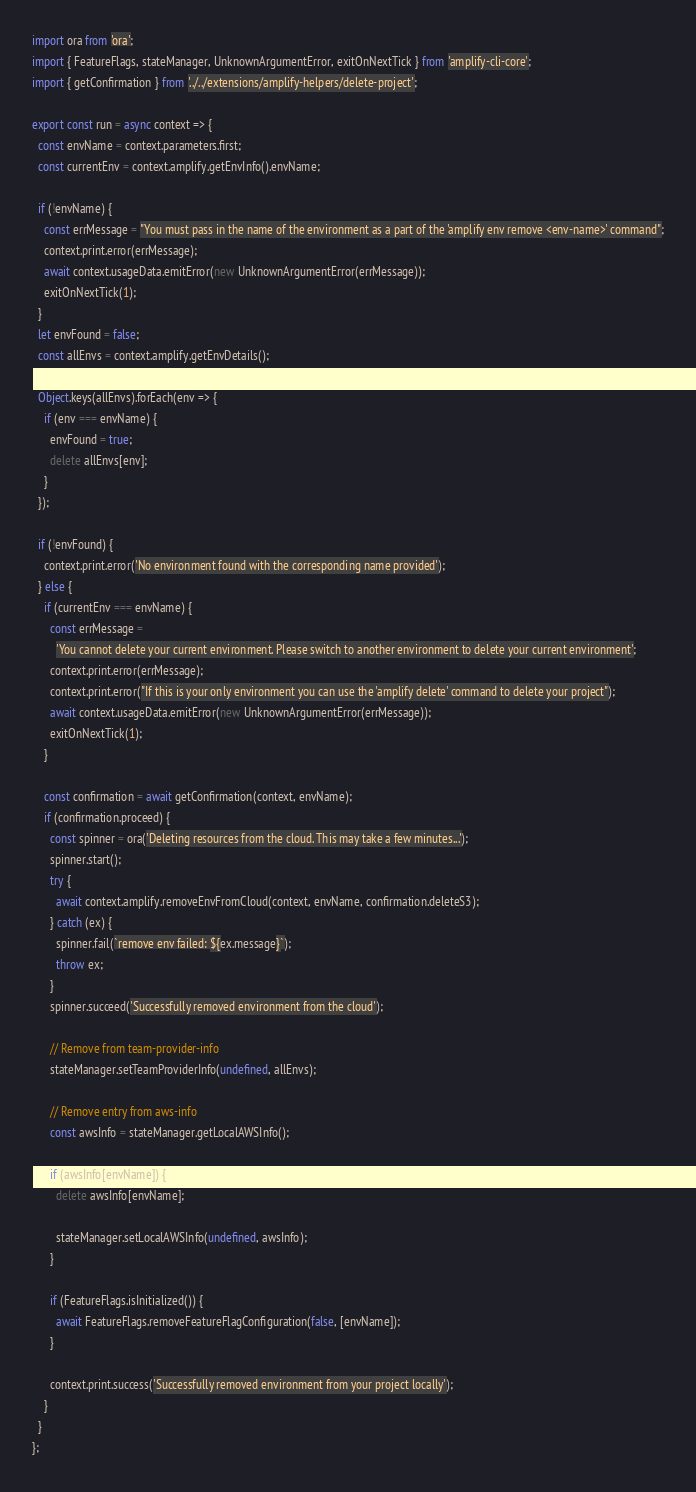<code> <loc_0><loc_0><loc_500><loc_500><_TypeScript_>import ora from 'ora';
import { FeatureFlags, stateManager, UnknownArgumentError, exitOnNextTick } from 'amplify-cli-core';
import { getConfirmation } from '../../extensions/amplify-helpers/delete-project';

export const run = async context => {
  const envName = context.parameters.first;
  const currentEnv = context.amplify.getEnvInfo().envName;

  if (!envName) {
    const errMessage = "You must pass in the name of the environment as a part of the 'amplify env remove <env-name>' command";
    context.print.error(errMessage);
    await context.usageData.emitError(new UnknownArgumentError(errMessage));
    exitOnNextTick(1);
  }
  let envFound = false;
  const allEnvs = context.amplify.getEnvDetails();

  Object.keys(allEnvs).forEach(env => {
    if (env === envName) {
      envFound = true;
      delete allEnvs[env];
    }
  });

  if (!envFound) {
    context.print.error('No environment found with the corresponding name provided');
  } else {
    if (currentEnv === envName) {
      const errMessage =
        'You cannot delete your current environment. Please switch to another environment to delete your current environment';
      context.print.error(errMessage);
      context.print.error("If this is your only environment you can use the 'amplify delete' command to delete your project");
      await context.usageData.emitError(new UnknownArgumentError(errMessage));
      exitOnNextTick(1);
    }

    const confirmation = await getConfirmation(context, envName);
    if (confirmation.proceed) {
      const spinner = ora('Deleting resources from the cloud. This may take a few minutes...');
      spinner.start();
      try {
        await context.amplify.removeEnvFromCloud(context, envName, confirmation.deleteS3);
      } catch (ex) {
        spinner.fail(`remove env failed: ${ex.message}`);
        throw ex;
      }
      spinner.succeed('Successfully removed environment from the cloud');

      // Remove from team-provider-info
      stateManager.setTeamProviderInfo(undefined, allEnvs);

      // Remove entry from aws-info
      const awsInfo = stateManager.getLocalAWSInfo();

      if (awsInfo[envName]) {
        delete awsInfo[envName];

        stateManager.setLocalAWSInfo(undefined, awsInfo);
      }

      if (FeatureFlags.isInitialized()) {
        await FeatureFlags.removeFeatureFlagConfiguration(false, [envName]);
      }

      context.print.success('Successfully removed environment from your project locally');
    }
  }
};
</code> 